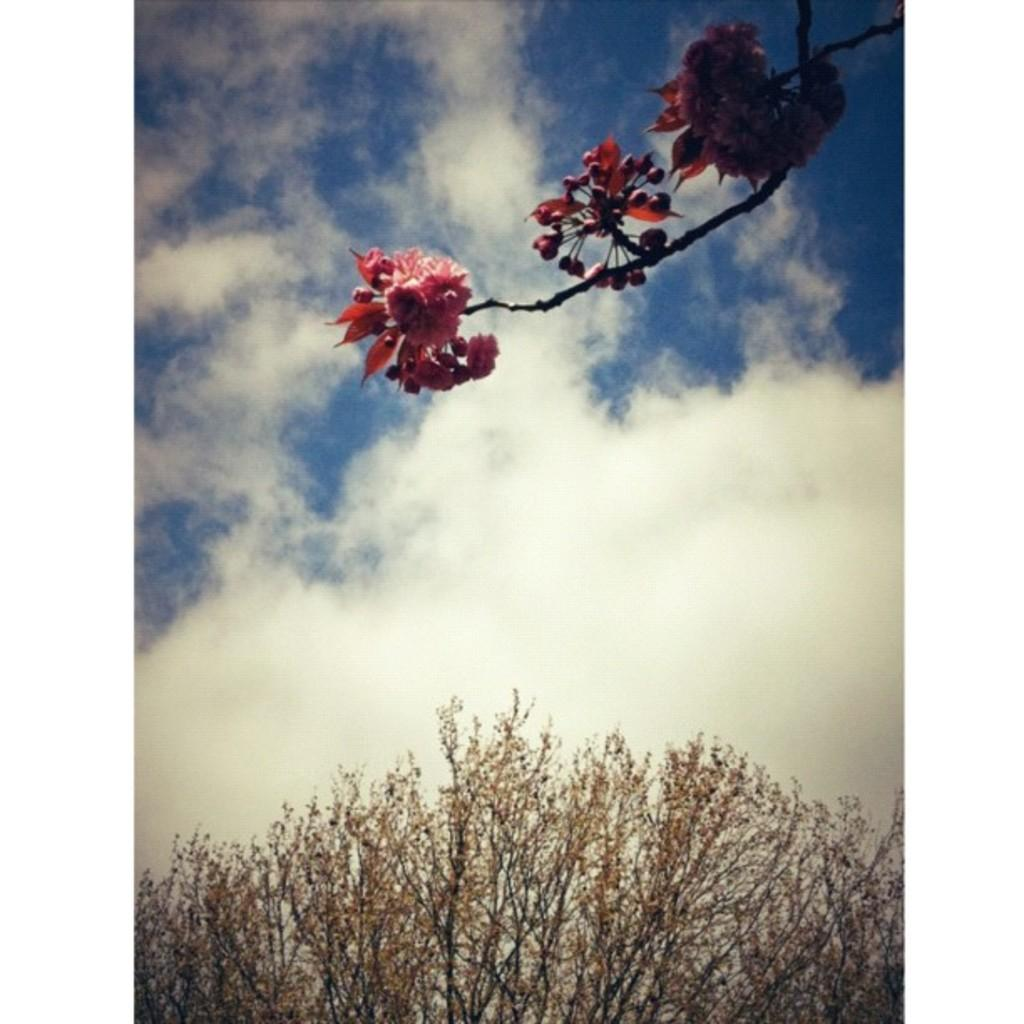What is the main subject of the image? The main subject of the image is a stem with flowers. What can be seen in the background of the image? There are clouds in the sky in the image. What type of vegetation is present at the bottom of the image? There are dried plants at the bottom of the image. What type of jeans is the grandmother wearing in the image? There is no grandmother or jeans present in the image. What type of trade is being conducted in the image? There is no trade being conducted in the image; it features a stem with flowers, clouds in the sky, and dried plants. 